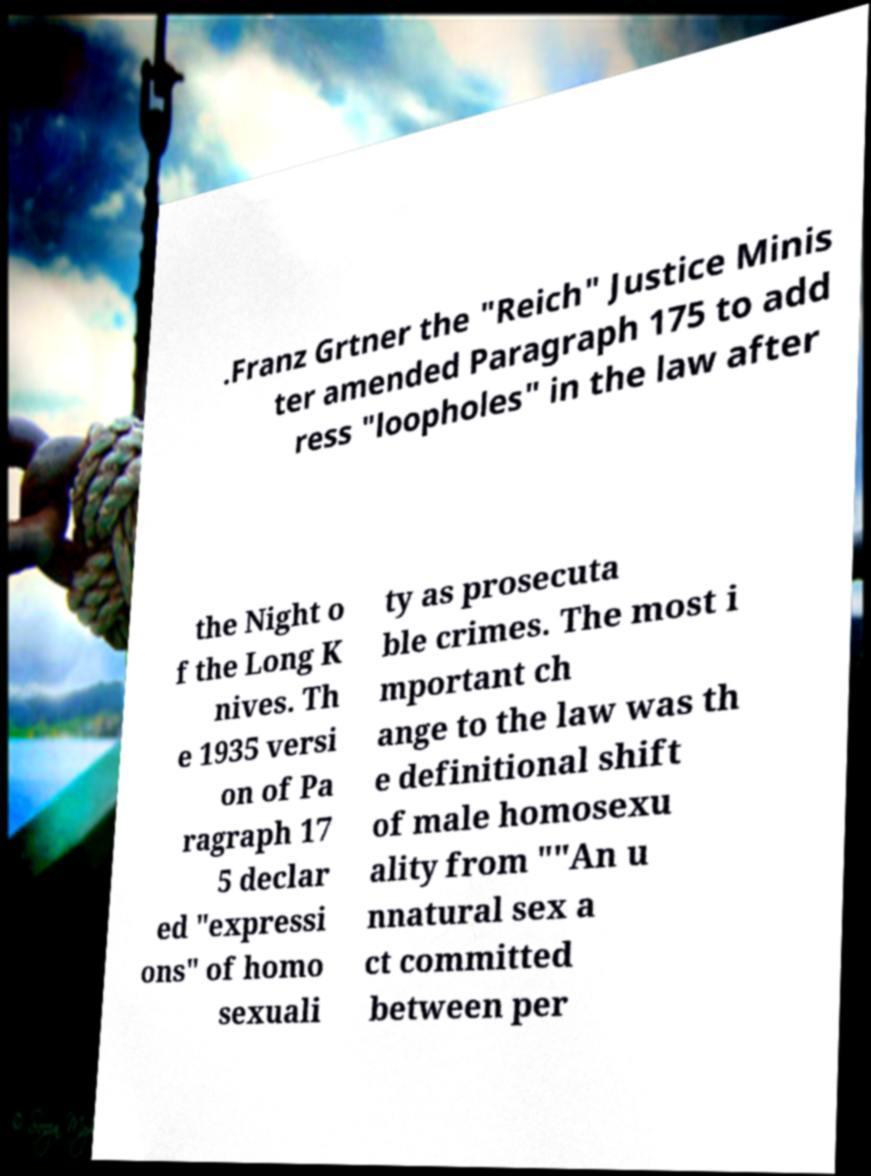Can you accurately transcribe the text from the provided image for me? .Franz Grtner the "Reich" Justice Minis ter amended Paragraph 175 to add ress "loopholes" in the law after the Night o f the Long K nives. Th e 1935 versi on of Pa ragraph 17 5 declar ed "expressi ons" of homo sexuali ty as prosecuta ble crimes. The most i mportant ch ange to the law was th e definitional shift of male homosexu ality from ""An u nnatural sex a ct committed between per 